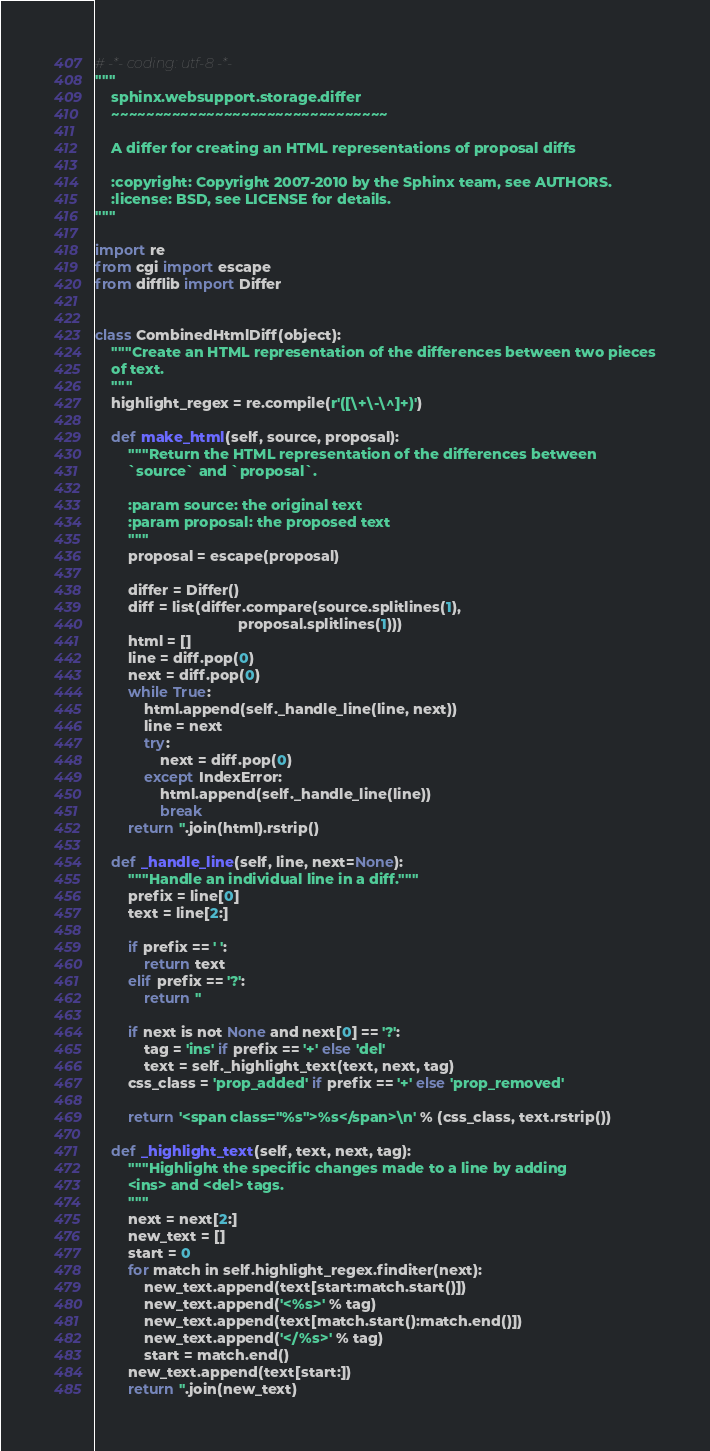Convert code to text. <code><loc_0><loc_0><loc_500><loc_500><_Python_># -*- coding: utf-8 -*-
"""
    sphinx.websupport.storage.differ
    ~~~~~~~~~~~~~~~~~~~~~~~~~~~~~~~~

    A differ for creating an HTML representations of proposal diffs

    :copyright: Copyright 2007-2010 by the Sphinx team, see AUTHORS.
    :license: BSD, see LICENSE for details.
"""

import re
from cgi import escape
from difflib import Differ


class CombinedHtmlDiff(object):
    """Create an HTML representation of the differences between two pieces
    of text.
    """
    highlight_regex = re.compile(r'([\+\-\^]+)')

    def make_html(self, source, proposal):
        """Return the HTML representation of the differences between
        `source` and `proposal`.

        :param source: the original text
        :param proposal: the proposed text
        """
        proposal = escape(proposal)

        differ = Differ()
        diff = list(differ.compare(source.splitlines(1),
                                   proposal.splitlines(1)))
        html = []
        line = diff.pop(0)
        next = diff.pop(0)
        while True:
            html.append(self._handle_line(line, next))
            line = next
            try:
                next = diff.pop(0)
            except IndexError:
                html.append(self._handle_line(line))
                break
        return ''.join(html).rstrip()

    def _handle_line(self, line, next=None):
        """Handle an individual line in a diff."""
        prefix = line[0]
        text = line[2:]

        if prefix == ' ':
            return text
        elif prefix == '?':
            return ''

        if next is not None and next[0] == '?':
            tag = 'ins' if prefix == '+' else 'del'
            text = self._highlight_text(text, next, tag)
        css_class = 'prop_added' if prefix == '+' else 'prop_removed'

        return '<span class="%s">%s</span>\n' % (css_class, text.rstrip())

    def _highlight_text(self, text, next, tag):
        """Highlight the specific changes made to a line by adding
        <ins> and <del> tags.
        """
        next = next[2:]
        new_text = []
        start = 0
        for match in self.highlight_regex.finditer(next):
            new_text.append(text[start:match.start()])
            new_text.append('<%s>' % tag)
            new_text.append(text[match.start():match.end()])
            new_text.append('</%s>' % tag)
            start = match.end()
        new_text.append(text[start:])
        return ''.join(new_text)
</code> 